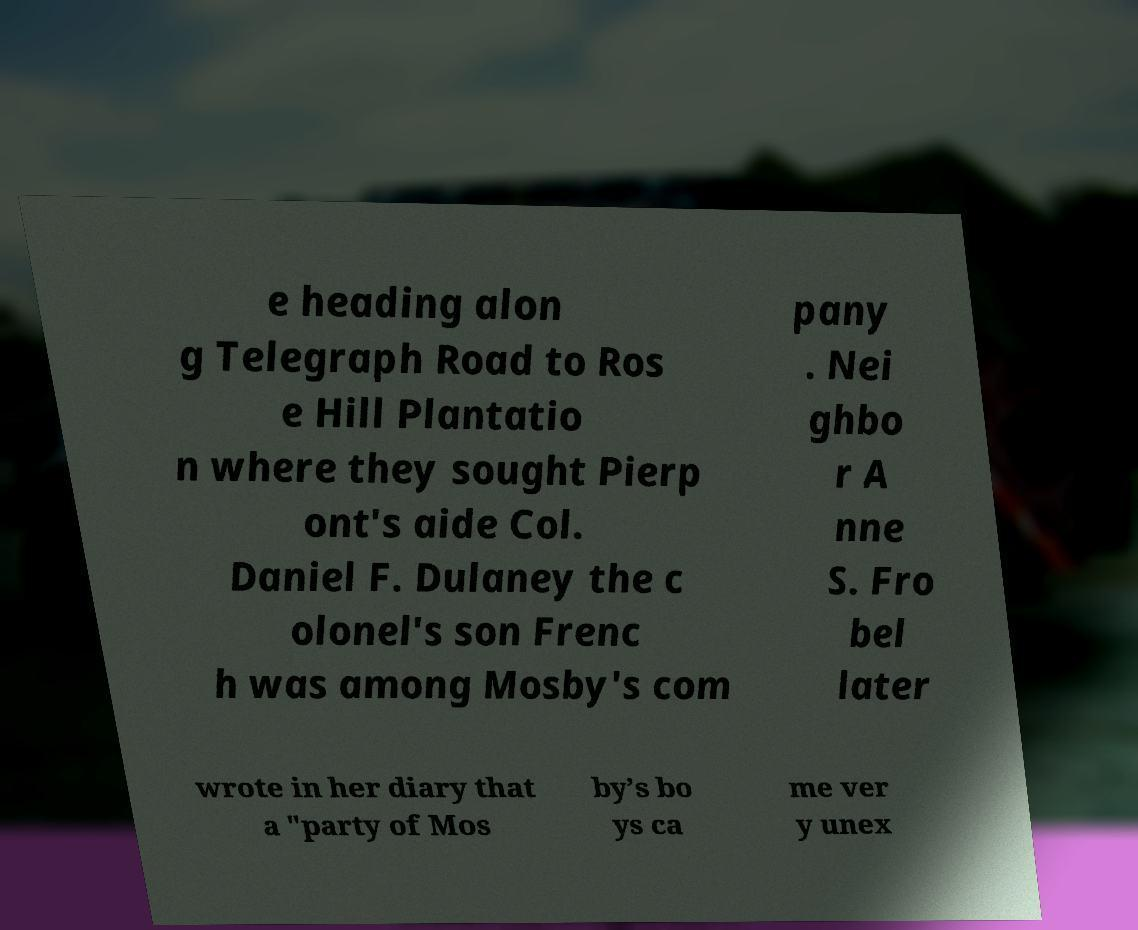For documentation purposes, I need the text within this image transcribed. Could you provide that? e heading alon g Telegraph Road to Ros e Hill Plantatio n where they sought Pierp ont's aide Col. Daniel F. Dulaney the c olonel's son Frenc h was among Mosby's com pany . Nei ghbo r A nne S. Fro bel later wrote in her diary that a "party of Mos by’s bo ys ca me ver y unex 